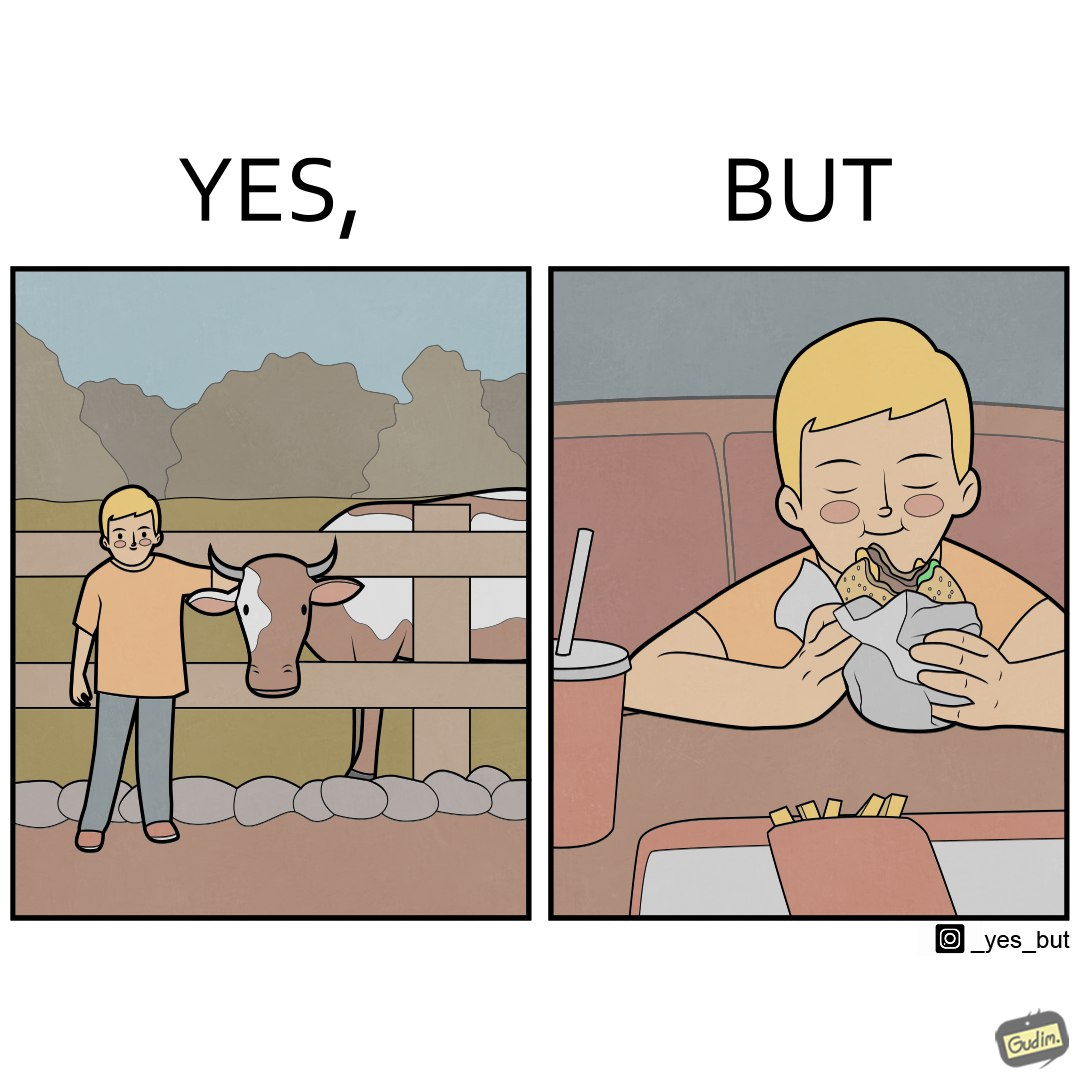Does this image contain satire or humor? Yes, this image is satirical. 